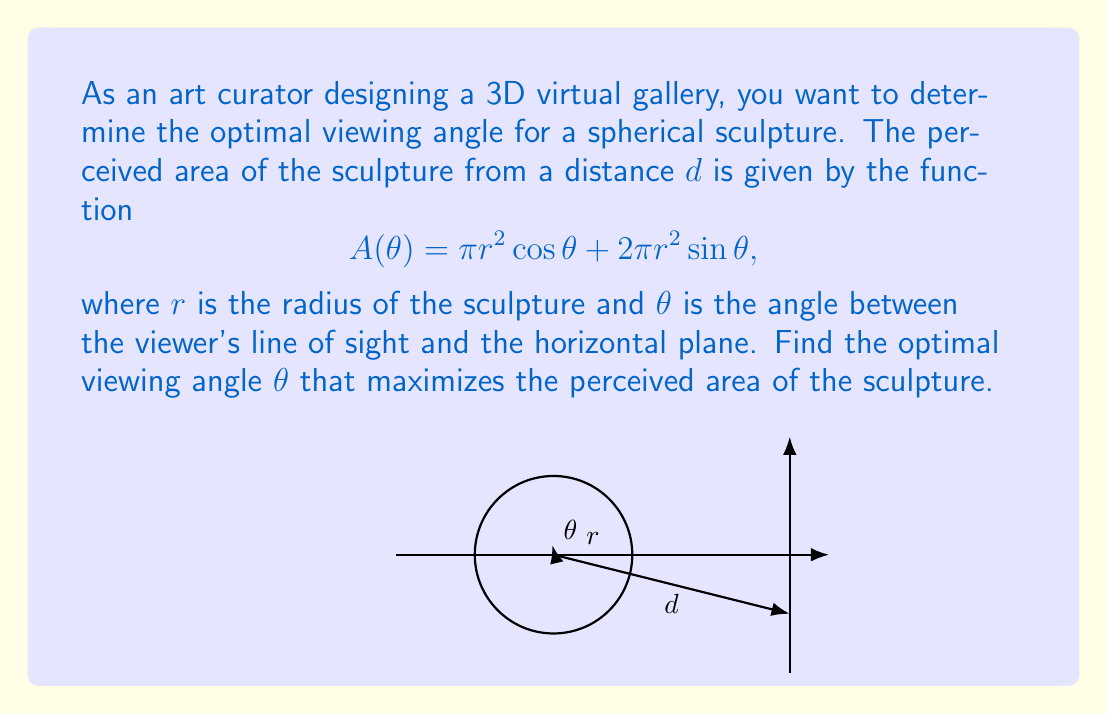Provide a solution to this math problem. To find the optimal viewing angle, we need to maximize the function $A(\theta)$. We can do this by finding the critical points using derivatives:

1) First, let's take the derivative of $A(\theta)$ with respect to $\theta$:

   $$\frac{dA}{d\theta} = -\pi r^2 \sin\theta + 2\pi r^2 \cos\theta$$

2) To find the critical points, we set this equal to zero:

   $$-\pi r^2 \sin\theta + 2\pi r^2 \cos\theta = 0$$

3) Factoring out $\pi r^2$:

   $$\pi r^2 (-\sin\theta + 2\cos\theta) = 0$$

4) Since $\pi r^2 \neq 0$, we solve:

   $$-\sin\theta + 2\cos\theta = 0$$

5) Dividing both sides by $\cos\theta$ (assuming $\cos\theta \neq 0$):

   $$-\tan\theta + 2 = 0$$

6) Solving for $\tan\theta$:

   $$\tan\theta = 2$$

7) Taking the inverse tangent of both sides:

   $$\theta = \arctan(2)$$

8) To confirm this is a maximum, we can check the second derivative:

   $$\frac{d^2A}{d\theta^2} = -\pi r^2 \cos\theta - 2\pi r^2 \sin\theta$$

   At $\theta = \arctan(2)$, this is negative, confirming a maximum.

Therefore, the optimal viewing angle is $\arctan(2)$ radians or approximately 63.4 degrees from the horizontal.
Answer: $\theta = \arctan(2)$ radians 